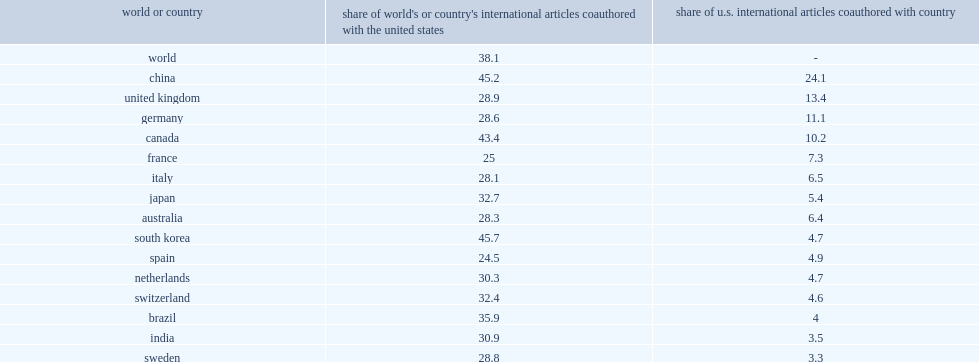How many percent of u.s. internationally coauthored articles in 2017. u.s. did researchers in china collaborate on? 24.1. How many percent did authors have substantial collaboration with authors from the united kingdom? 13.4. How many percent did authors have substantial collaboration with authors from germany? 11.1. How many percent did authors have substantial collaboration with authors from canada? 10.2. 